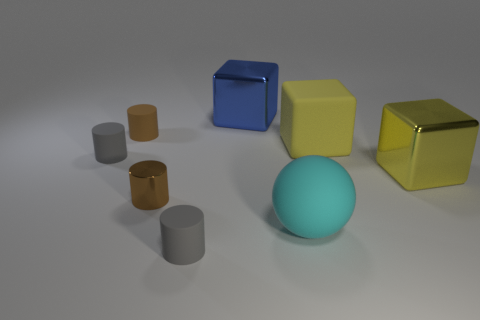Subtract all metallic cubes. How many cubes are left? 1 Add 2 big objects. How many objects exist? 10 Subtract all brown cylinders. How many cylinders are left? 2 Subtract 1 spheres. How many spheres are left? 0 Subtract all yellow cubes. Subtract all red cylinders. How many cubes are left? 1 Subtract all purple blocks. How many brown cylinders are left? 2 Subtract all big gray matte objects. Subtract all matte cylinders. How many objects are left? 5 Add 4 small brown rubber objects. How many small brown rubber objects are left? 5 Add 5 tiny metal objects. How many tiny metal objects exist? 6 Subtract 0 purple cylinders. How many objects are left? 8 